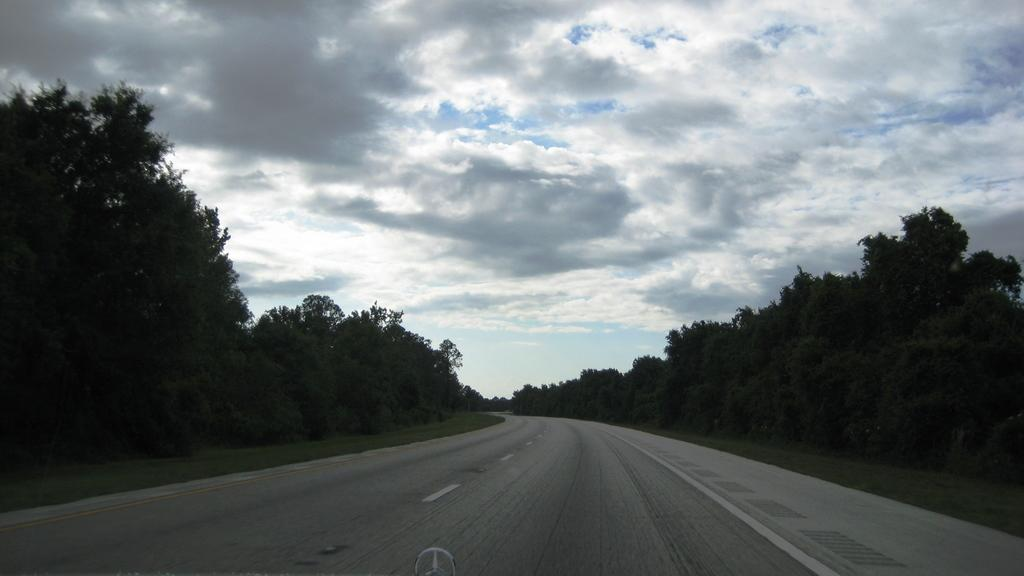What is the main feature of the image? There is a road in the image. What type of vegetation can be seen on both sides of the road? There are green color trees on the right side and the left side of the image. What is visible at the top of the image? The sky is visible at the top of the image. What is the condition of the sky in the image? The sky is cloudy in the image. What type of net can be seen catching fish in the image? There is no net or fish present in the image; it features a road with green color trees on both sides and a cloudy sky. What type of bag is the person carrying while answering questions in the image? There is no person carrying a bag or answering questions in the image. 